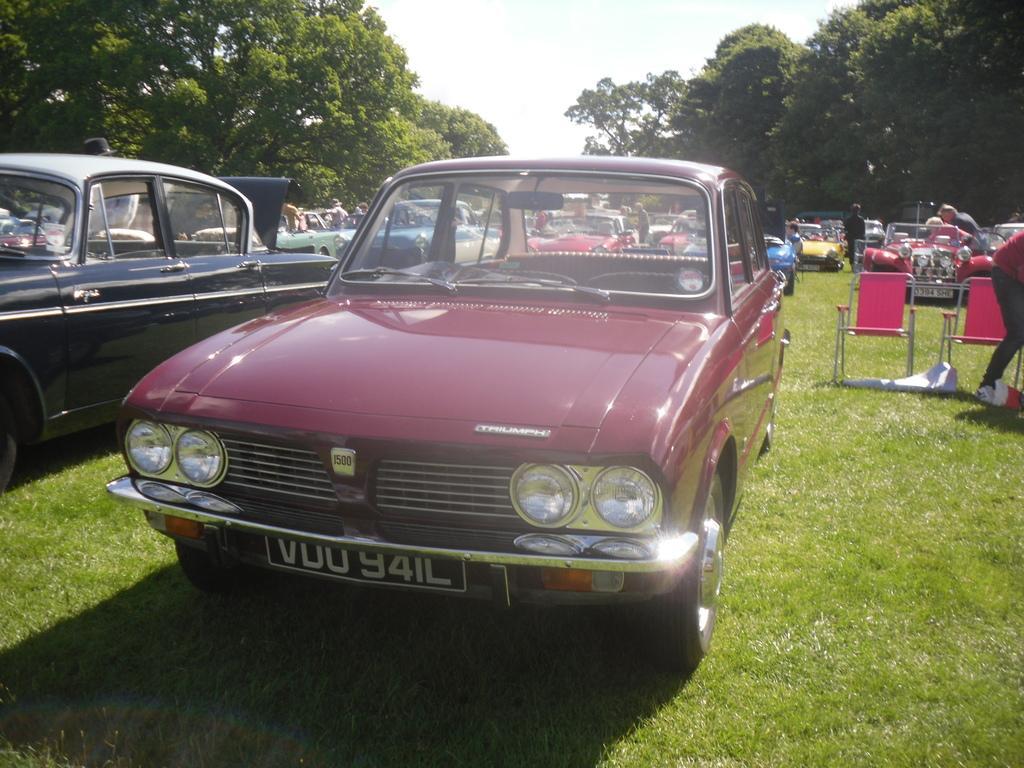Could you give a brief overview of what you see in this image? In this picture there is a red color car which is on the ground. On the left we can see blue color car. On the right there is a man who is wearing a red t-shirt, trouser and shoe. He is standing near to the chair. On the background we can see many people standing near to the cars. On the top right we can see many trees. On the top we can see sky and clouds. 